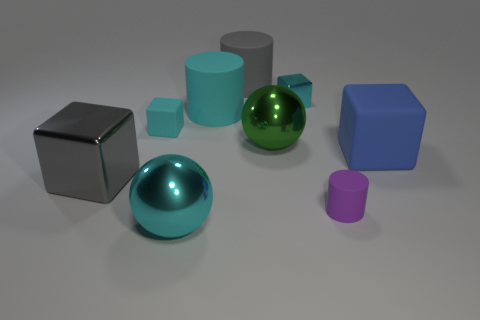What textures are visible on the objects? The objects in the image have different textures. The two cubes, one silver and one blue, have a matte texture. The spheres and the cylinders appear smoother and have a reflective surface, giving them a glossy texture. 